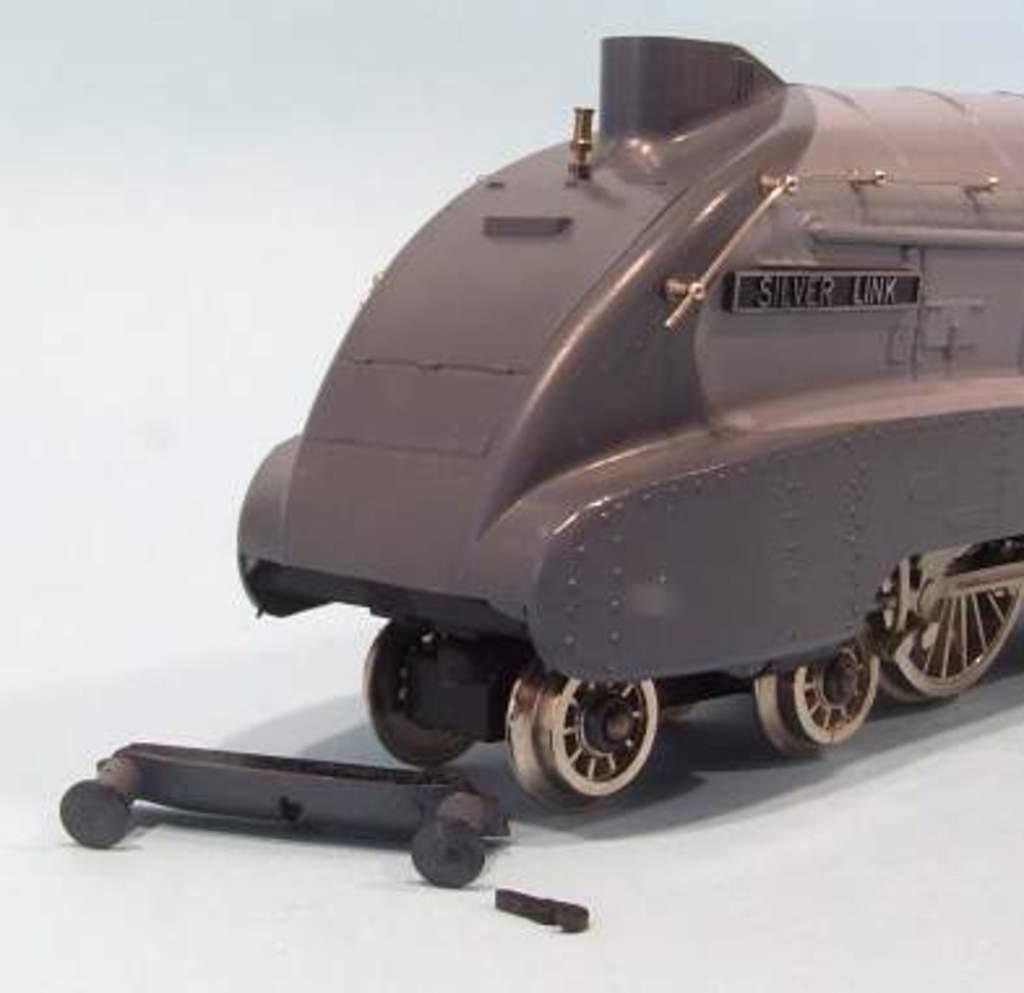In one or two sentences, can you explain what this image depicts? This image, it's a thing which looks like a train, there are wheels in this thing. 